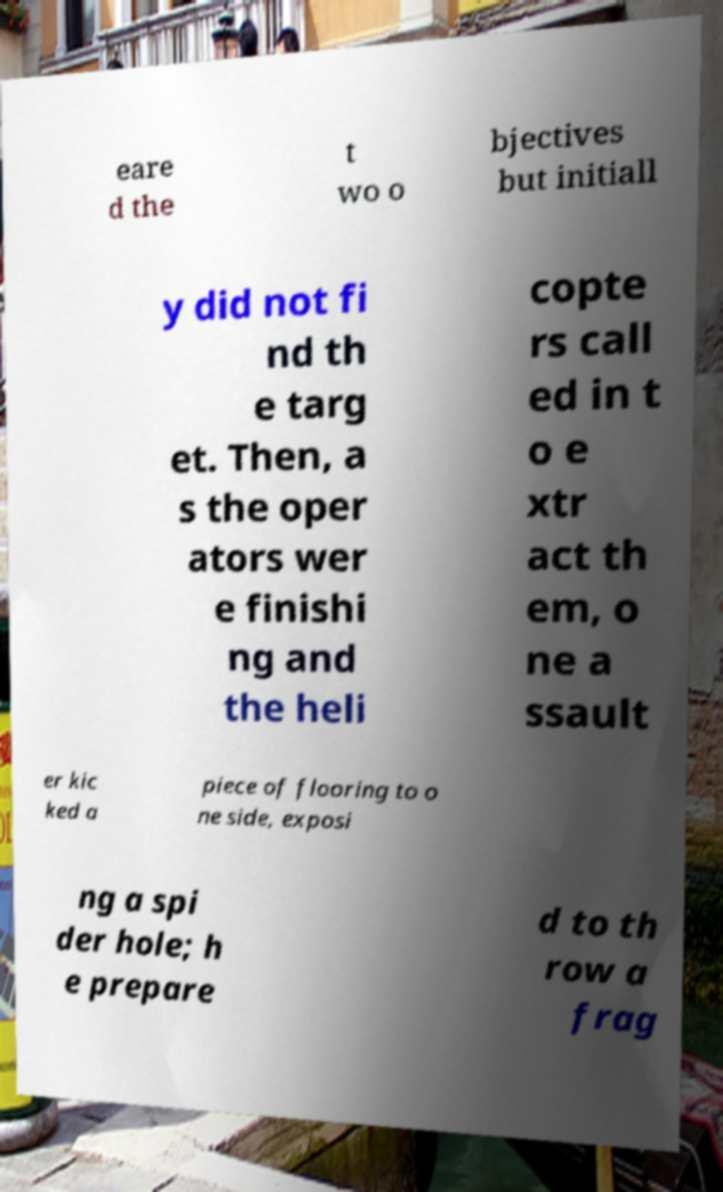I need the written content from this picture converted into text. Can you do that? eare d the t wo o bjectives but initiall y did not fi nd th e targ et. Then, a s the oper ators wer e finishi ng and the heli copte rs call ed in t o e xtr act th em, o ne a ssault er kic ked a piece of flooring to o ne side, exposi ng a spi der hole; h e prepare d to th row a frag 